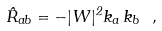<formula> <loc_0><loc_0><loc_500><loc_500>\hat { R } _ { a b } = - | W | ^ { 2 } k _ { a } \, k _ { b } \ ,</formula> 